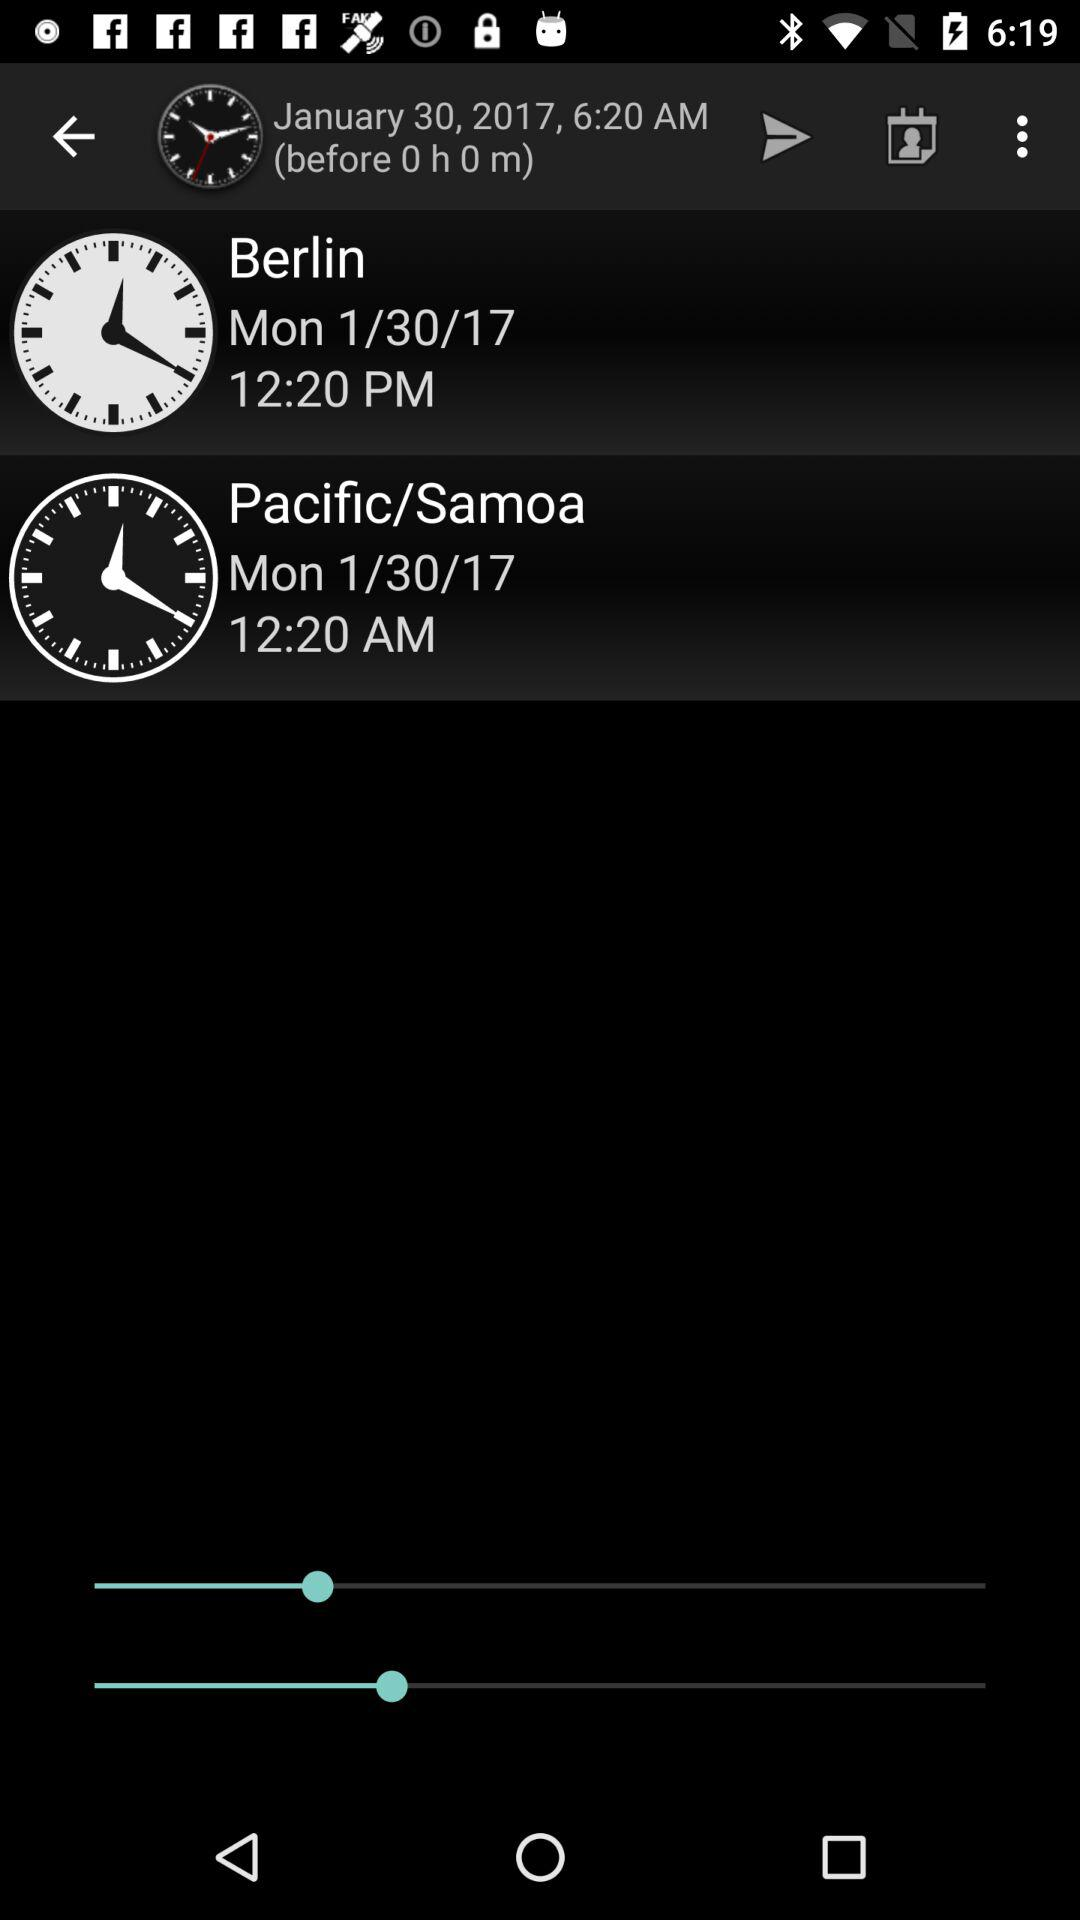What is the date of the Pacific/ Samoa? The date is Monday, January 30, 2017. 